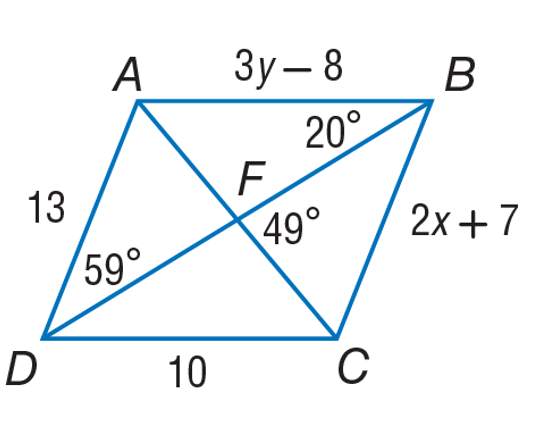Could you explain the relationship between angles A and C in parallelogram ABCD? Certainly! In a parallelogram, opposite angles are congruent. That means angle A and angle C are equal in measure. Since in the given image angle A isn't directly labeled but we can see angle D is 59 degrees and angle B is 20 degrees, we can calculate angle C. The adjacent angles in a parallelogram are supplementary. Therefore, angle C would also be 59 degrees, and angle A would be congruent to angle C, giving us 59 degrees for both angle A and angle C. 